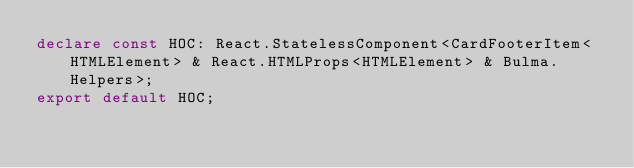<code> <loc_0><loc_0><loc_500><loc_500><_TypeScript_>declare const HOC: React.StatelessComponent<CardFooterItem<HTMLElement> & React.HTMLProps<HTMLElement> & Bulma.Helpers>;
export default HOC;
</code> 